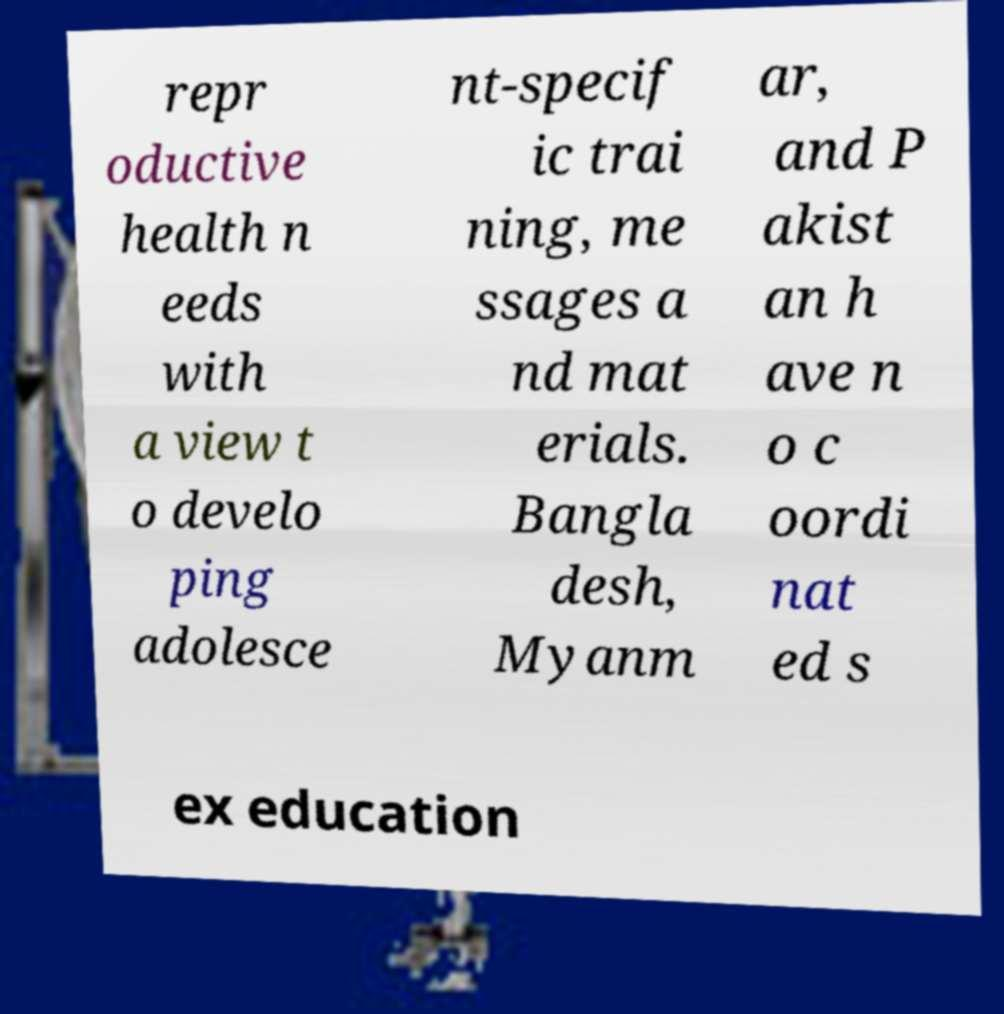Please identify and transcribe the text found in this image. repr oductive health n eeds with a view t o develo ping adolesce nt-specif ic trai ning, me ssages a nd mat erials. Bangla desh, Myanm ar, and P akist an h ave n o c oordi nat ed s ex education 